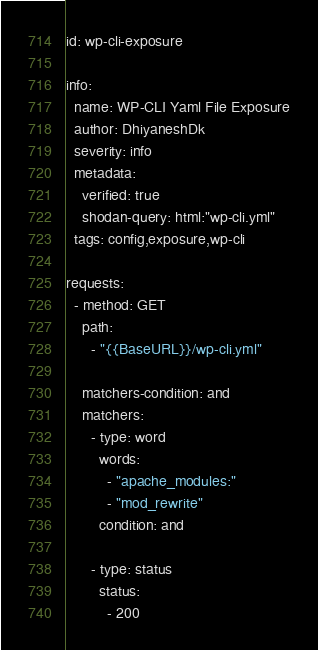Convert code to text. <code><loc_0><loc_0><loc_500><loc_500><_YAML_>id: wp-cli-exposure

info:
  name: WP-CLI Yaml File Exposure
  author: DhiyaneshDk
  severity: info
  metadata:
    verified: true
    shodan-query: html:"wp-cli.yml"
  tags: config,exposure,wp-cli

requests:
  - method: GET
    path:
      - "{{BaseURL}}/wp-cli.yml"

    matchers-condition: and
    matchers:
      - type: word
        words:
          - "apache_modules:"
          - "mod_rewrite"
        condition: and

      - type: status
        status:
          - 200
</code> 